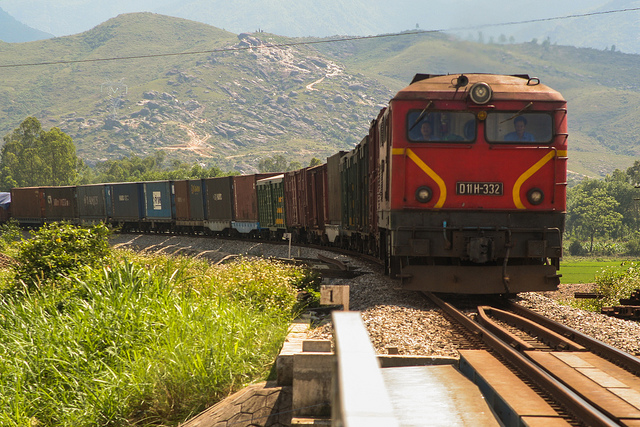Identify the text contained in this image. 0 11 H-332 